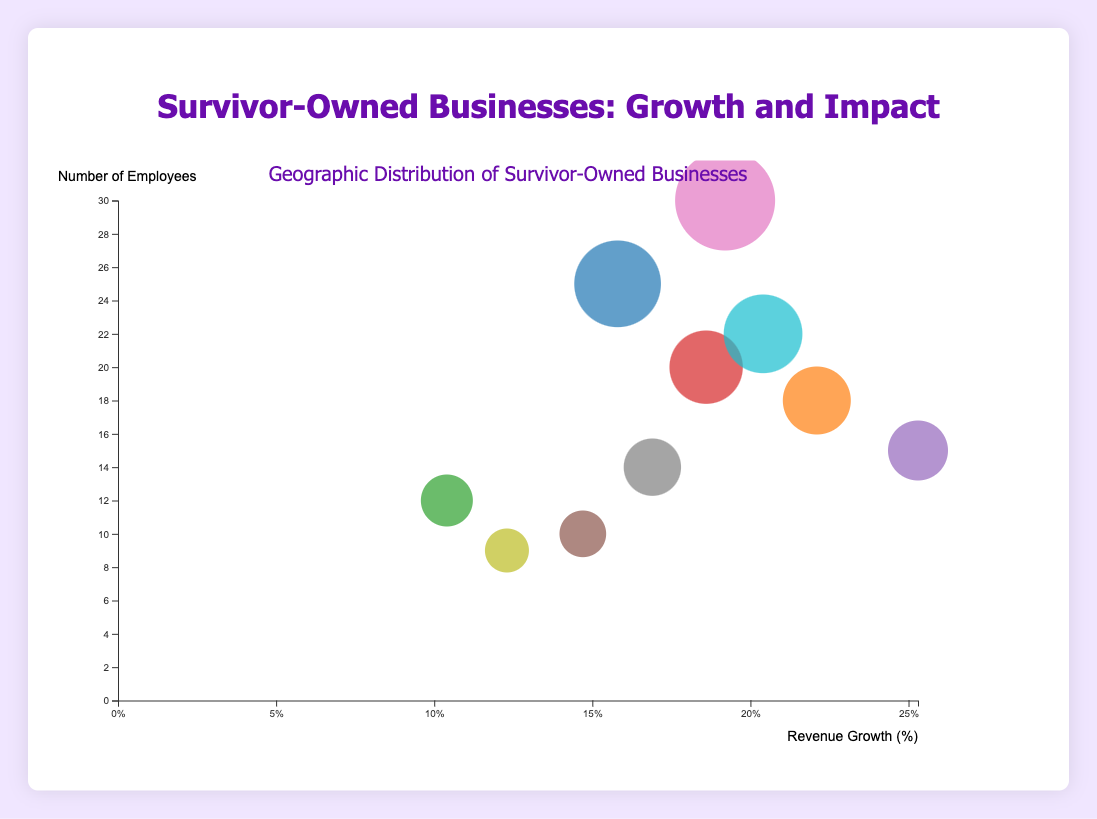What is the highest revenue growth percentage among the businesses? To determine this, find the business with the highest value on the x-axis, which represents revenue growth percentage. Graceful Bakery in Phoenix, AZ has the highest revenue growth percentage of 25.3%
Answer: 25.3% How many businesses have more than 20 employees? Identify the bubbles that are above the '20' mark on the y-axis. Courage Cafe, Empower Fitness, Brave Tech, and Phoenix Rise Consulting have more than 20 employees.
Answer: 4 Which business in California has the highest number of employees? Look for bubbles representing businesses in California, identify them by their distinct colors, and compare their y-axis values (number of employees). Phoenix Rise Consulting in San Jose, CA has 22 employees.
Answer: Phoenix Rise Consulting What is the average revenue growth percentage of the businesses with 15 or more employees? Focus on bubbles with a y-axis value of 15 or higher, then find their revenue growth percentages: Courage Cafe (15.8), Resilience Boutique (22.1), Empower Fitness (18.6), Graceful Bakery (25.3), Brave Tech (19.2), Inspire Jewelry (16.9), Phoenix Rise Consulting (20.4). Calculate the average: (15.8 + 22.1 + 18.6 + 25.3 + 19.2 + 16.9 + 20.4)/7 ≈ 19.61%
Answer: 19.61% Which business has the smallest bubble size, and what does it represent visually? Locate the smallest bubble on the chart and check its details. Freedom Bookstore has the smallest bubble, representing the smallest number of employees, which is 9.
Answer: Freedom Bookstore, 9 employees Which city has the greatest number of survivor-owned businesses represented? Count the bubbles associated with each city. San Diego, CA has 3 businesses: Resilience Boutique, Inspire Jewelry, and Phoenix Rise Consulting.
Answer: San Diego, CA If you were to combine the number of employees of all businesses in Texas, what would the total be? Identify the bubbles for businesses in Texas (Houston, San Antonio, Dallas), sum their number of employees: Empower Fitness (20), Brave Tech (30), Freedom Bookstore (9). Calculate the total: 20 + 30 + 9 = 59
Answer: 59 Which business has a higher revenue growth percentage: Survivor Spa in Philadelphia, PA or Freedom Bookstore in Dallas, TX? Compare their x-axis values. Survivor Spa has a revenue growth of 14.7% and Freedom Bookstore has 12.3%. Therefore, Survivor Spa has a higher revenue growth percentage.
Answer: Survivor Spa What is the median number of employees for all businesses shown in the chart? List the number of employees of all businesses and find the median value: [9, 10, 12, 14, 15, 18, 20, 22, 25, 30]. Median value is at the middle point (or average of two middle points): (15+18)/2 = 16.5.
Answer: 16.5 Which business represents the highest combination of revenue growth percentage and number of employees? Look for the bubble positioned highest and furthest right, where both x (revenue growth) and y values (number of employees) are maximized together. Graceful Bakery in Phoenix, AZ achieves the highest combination of 25.3% and 15 employees.
Answer: Graceful Bakery 